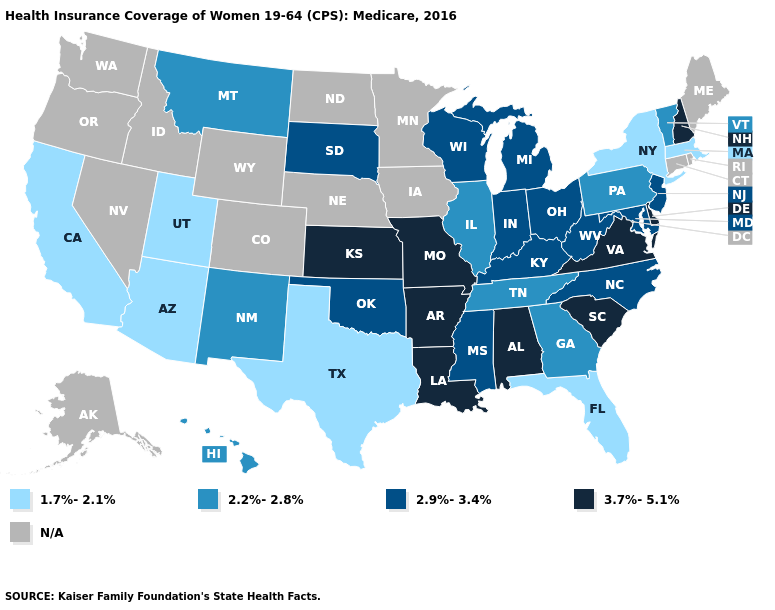Is the legend a continuous bar?
Short answer required. No. Name the states that have a value in the range 2.9%-3.4%?
Concise answer only. Indiana, Kentucky, Maryland, Michigan, Mississippi, New Jersey, North Carolina, Ohio, Oklahoma, South Dakota, West Virginia, Wisconsin. What is the highest value in the USA?
Keep it brief. 3.7%-5.1%. Does Florida have the lowest value in the USA?
Concise answer only. Yes. What is the value of Vermont?
Short answer required. 2.2%-2.8%. Which states have the lowest value in the USA?
Give a very brief answer. Arizona, California, Florida, Massachusetts, New York, Texas, Utah. Name the states that have a value in the range 3.7%-5.1%?
Keep it brief. Alabama, Arkansas, Delaware, Kansas, Louisiana, Missouri, New Hampshire, South Carolina, Virginia. What is the highest value in the MidWest ?
Keep it brief. 3.7%-5.1%. What is the value of South Carolina?
Quick response, please. 3.7%-5.1%. What is the value of Massachusetts?
Quick response, please. 1.7%-2.1%. What is the value of Michigan?
Quick response, please. 2.9%-3.4%. What is the highest value in the West ?
Be succinct. 2.2%-2.8%. Name the states that have a value in the range 1.7%-2.1%?
Give a very brief answer. Arizona, California, Florida, Massachusetts, New York, Texas, Utah. What is the lowest value in states that border Oregon?
Short answer required. 1.7%-2.1%. 